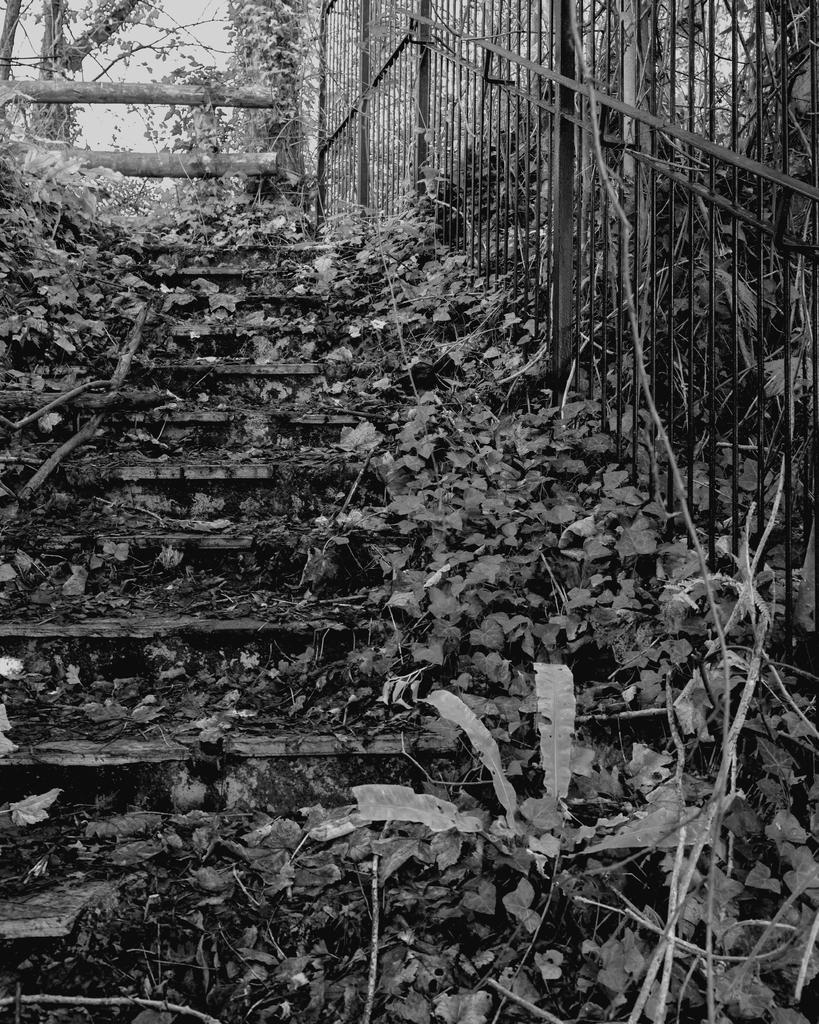What type of structure is present in the image? There is a staircase in the image. What other objects can be seen in the image? There is a group of plants and a fence in the image. What can be seen in the background of the image? There are trees, wood pieces, and the sky visible in the background of the image. What is the value of the wilderness depicted in the image? There is no wilderness depicted in the image; it features a staircase, plants, a fence, trees, wood pieces, and the sky. Can you tell me how many people are taking a bath in the image? There are no people or baths present in the image. 